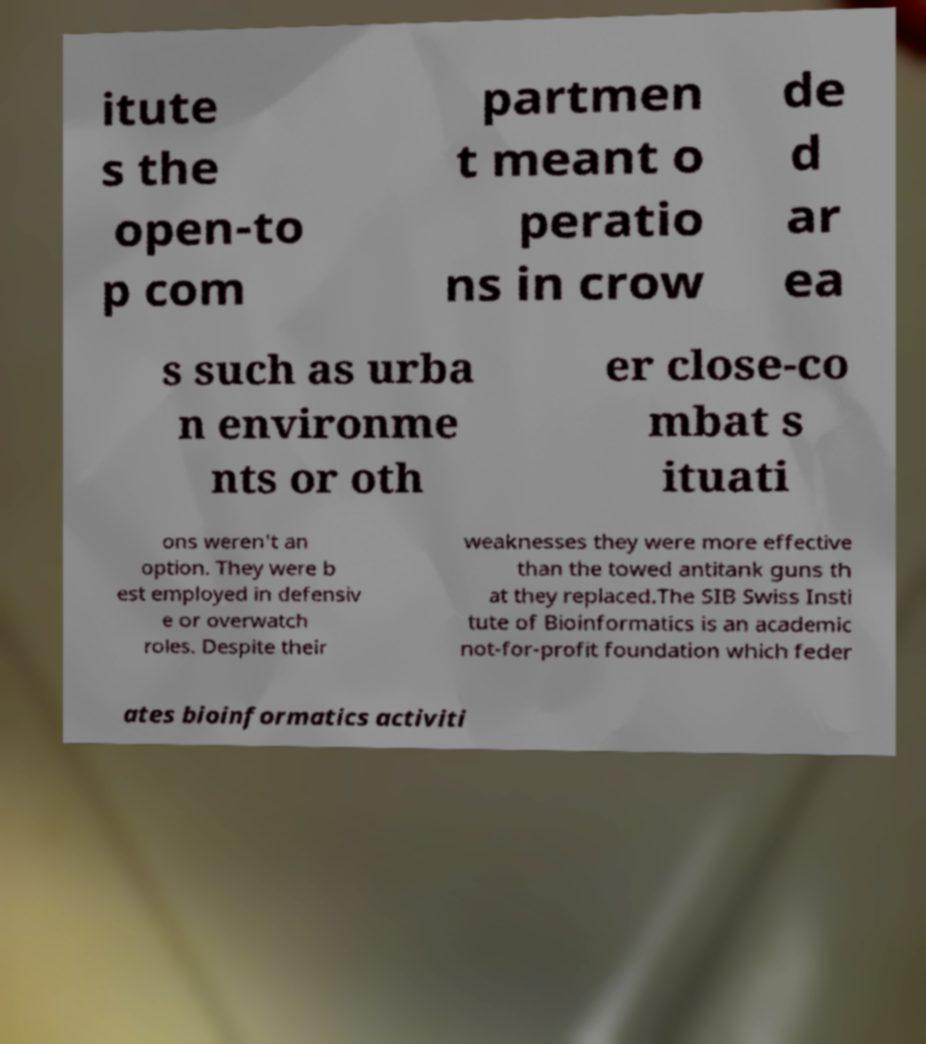For documentation purposes, I need the text within this image transcribed. Could you provide that? itute s the open-to p com partmen t meant o peratio ns in crow de d ar ea s such as urba n environme nts or oth er close-co mbat s ituati ons weren't an option. They were b est employed in defensiv e or overwatch roles. Despite their weaknesses they were more effective than the towed antitank guns th at they replaced.The SIB Swiss Insti tute of Bioinformatics is an academic not-for-profit foundation which feder ates bioinformatics activiti 